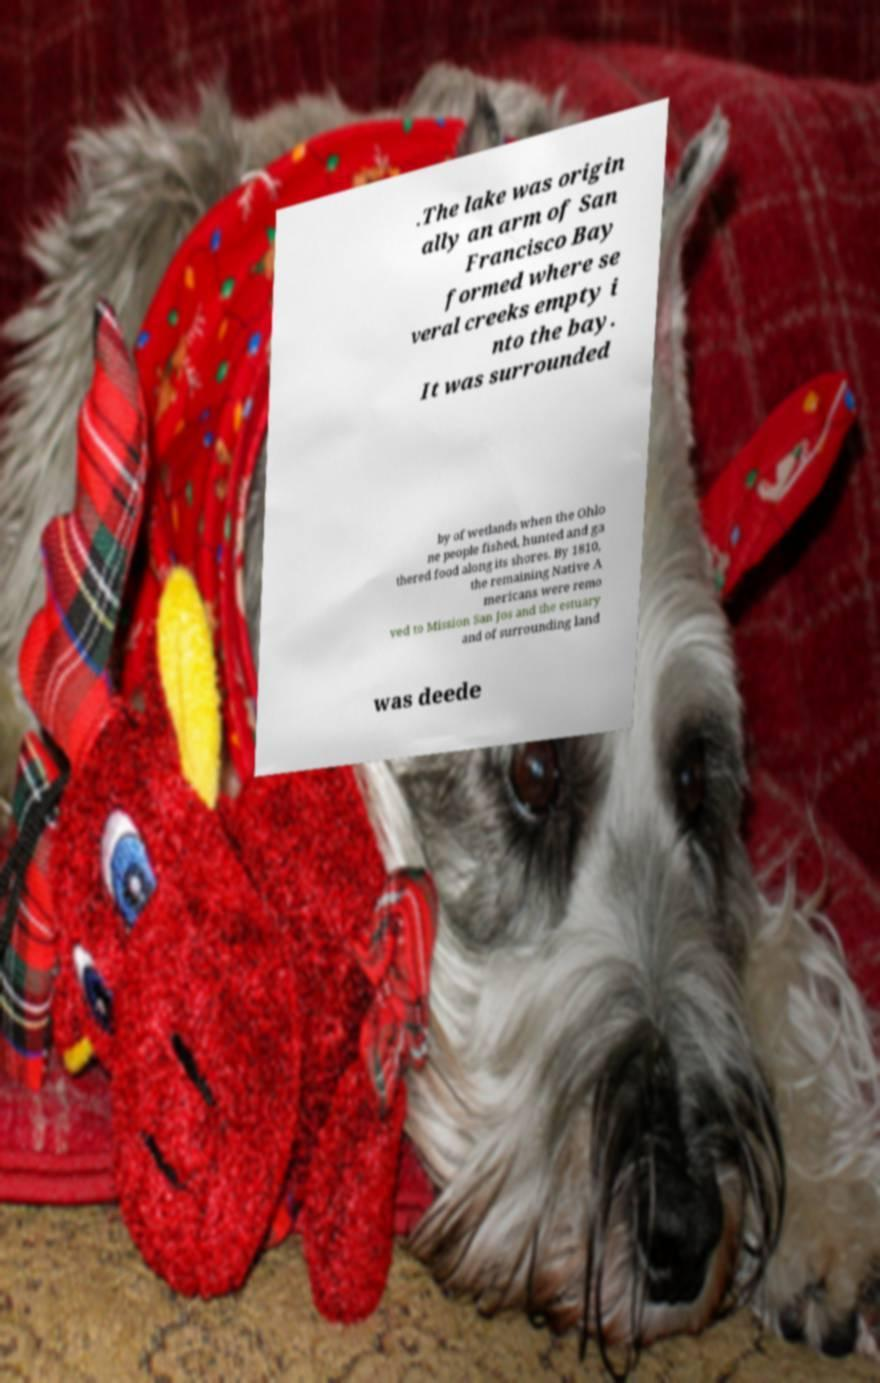What messages or text are displayed in this image? I need them in a readable, typed format. .The lake was origin ally an arm of San Francisco Bay formed where se veral creeks empty i nto the bay. It was surrounded by of wetlands when the Ohlo ne people fished, hunted and ga thered food along its shores. By 1810, the remaining Native A mericans were remo ved to Mission San Jos and the estuary and of surrounding land was deede 